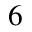Convert formula to latex. <formula><loc_0><loc_0><loc_500><loc_500>6</formula> 